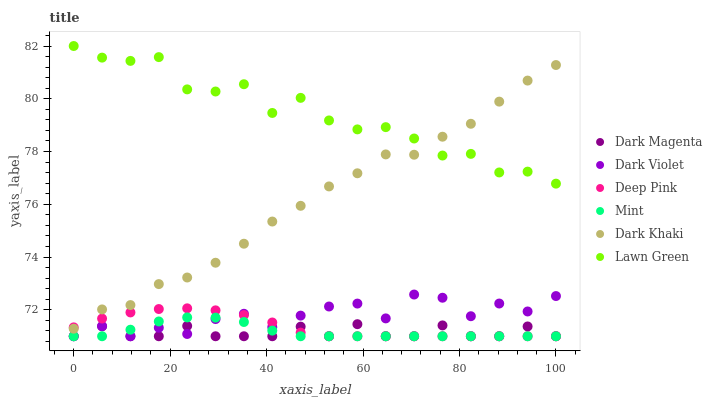Does Dark Magenta have the minimum area under the curve?
Answer yes or no. Yes. Does Lawn Green have the maximum area under the curve?
Answer yes or no. Yes. Does Deep Pink have the minimum area under the curve?
Answer yes or no. No. Does Deep Pink have the maximum area under the curve?
Answer yes or no. No. Is Deep Pink the smoothest?
Answer yes or no. Yes. Is Lawn Green the roughest?
Answer yes or no. Yes. Is Dark Magenta the smoothest?
Answer yes or no. No. Is Dark Magenta the roughest?
Answer yes or no. No. Does Deep Pink have the lowest value?
Answer yes or no. Yes. Does Dark Khaki have the lowest value?
Answer yes or no. No. Does Lawn Green have the highest value?
Answer yes or no. Yes. Does Deep Pink have the highest value?
Answer yes or no. No. Is Dark Magenta less than Dark Khaki?
Answer yes or no. Yes. Is Dark Khaki greater than Mint?
Answer yes or no. Yes. Does Dark Violet intersect Mint?
Answer yes or no. Yes. Is Dark Violet less than Mint?
Answer yes or no. No. Is Dark Violet greater than Mint?
Answer yes or no. No. Does Dark Magenta intersect Dark Khaki?
Answer yes or no. No. 